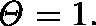<formula> <loc_0><loc_0><loc_500><loc_500>\Theta = 1 .</formula> 